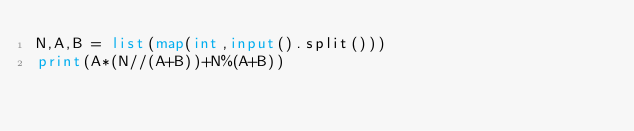<code> <loc_0><loc_0><loc_500><loc_500><_Python_>N,A,B = list(map(int,input().split()))
print(A*(N//(A+B))+N%(A+B))</code> 